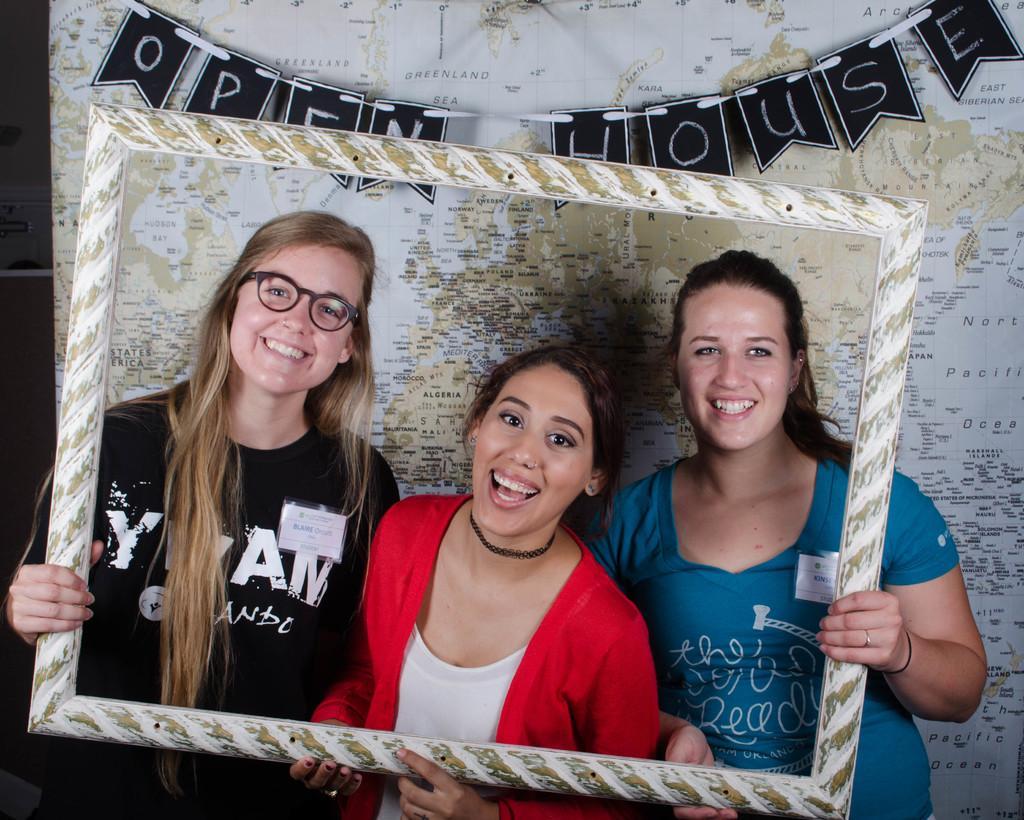In one or two sentences, can you explain what this image depicts? At the bottom of this image, there are three women in different color dresses, holding a frame, smiling and standing. In the background, there is a map. 